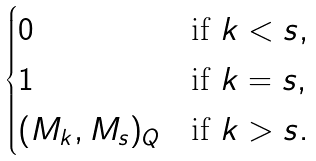Convert formula to latex. <formula><loc_0><loc_0><loc_500><loc_500>\begin{cases} 0 & \text {if $k < s$} , \\ 1 & \text {if $k = s$} , \\ ( M _ { k } , M _ { s } ) _ { Q } & \text {if $k > s$} . \end{cases}</formula> 